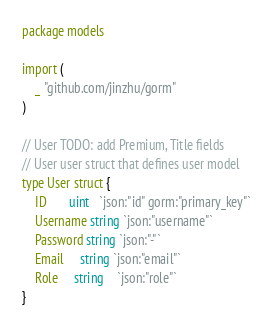<code> <loc_0><loc_0><loc_500><loc_500><_Go_>package models

import (
	_ "github.com/jinzhu/gorm"
)

// User TODO: add Premium, Title fields
// User user struct that defines user model
type User struct {
	ID       uint   `json:"id" gorm:"primary_key"`
	Username string `json:"username"`
	Password string `json:"-"`
	Email	 string `json:"email"`
	Role     string	`json:"role"`
}
</code> 